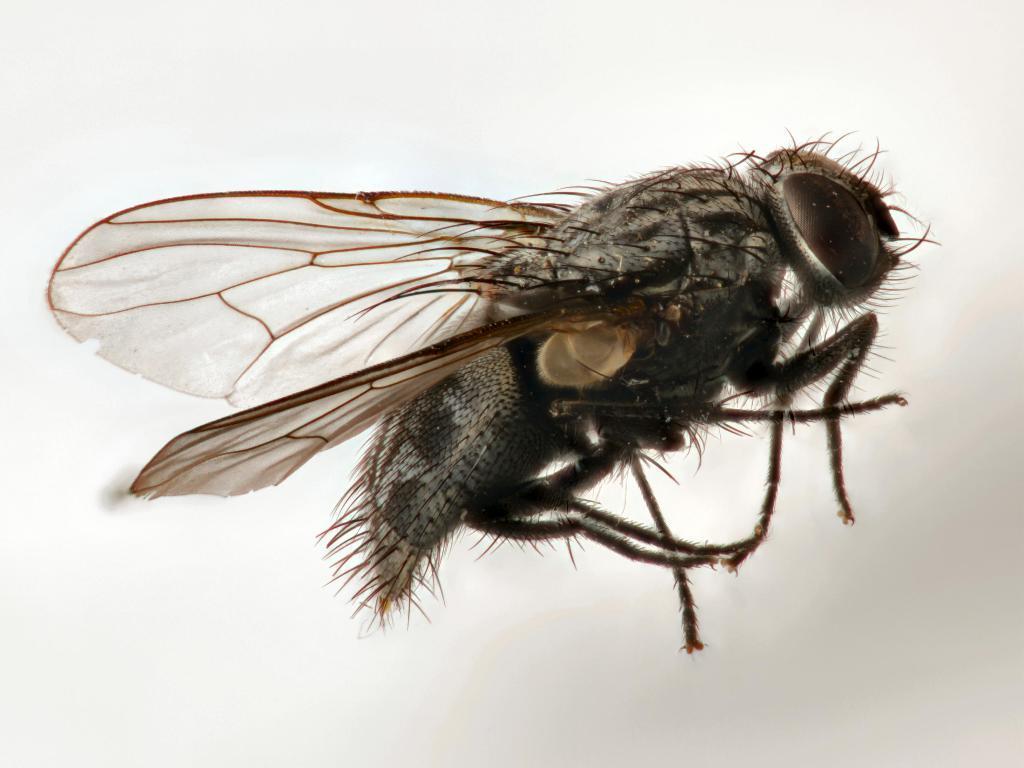How would you summarize this image in a sentence or two? In this image I can see a fly which is facing toward the right side. 